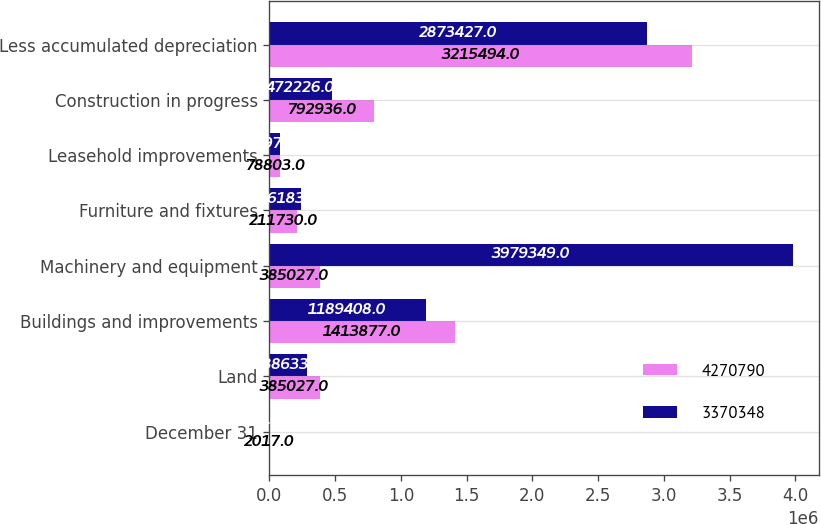Convert chart to OTSL. <chart><loc_0><loc_0><loc_500><loc_500><stacked_bar_chart><ecel><fcel>December 31<fcel>Land<fcel>Buildings and improvements<fcel>Machinery and equipment<fcel>Furniture and fixtures<fcel>Leasehold improvements<fcel>Construction in progress<fcel>Less accumulated depreciation<nl><fcel>4.27079e+06<fcel>2017<fcel>385027<fcel>1.41388e+06<fcel>385027<fcel>211730<fcel>78803<fcel>792936<fcel>3.21549e+06<nl><fcel>3.37035e+06<fcel>2016<fcel>288633<fcel>1.18941e+06<fcel>3.97935e+06<fcel>236183<fcel>77976<fcel>472226<fcel>2.87343e+06<nl></chart> 